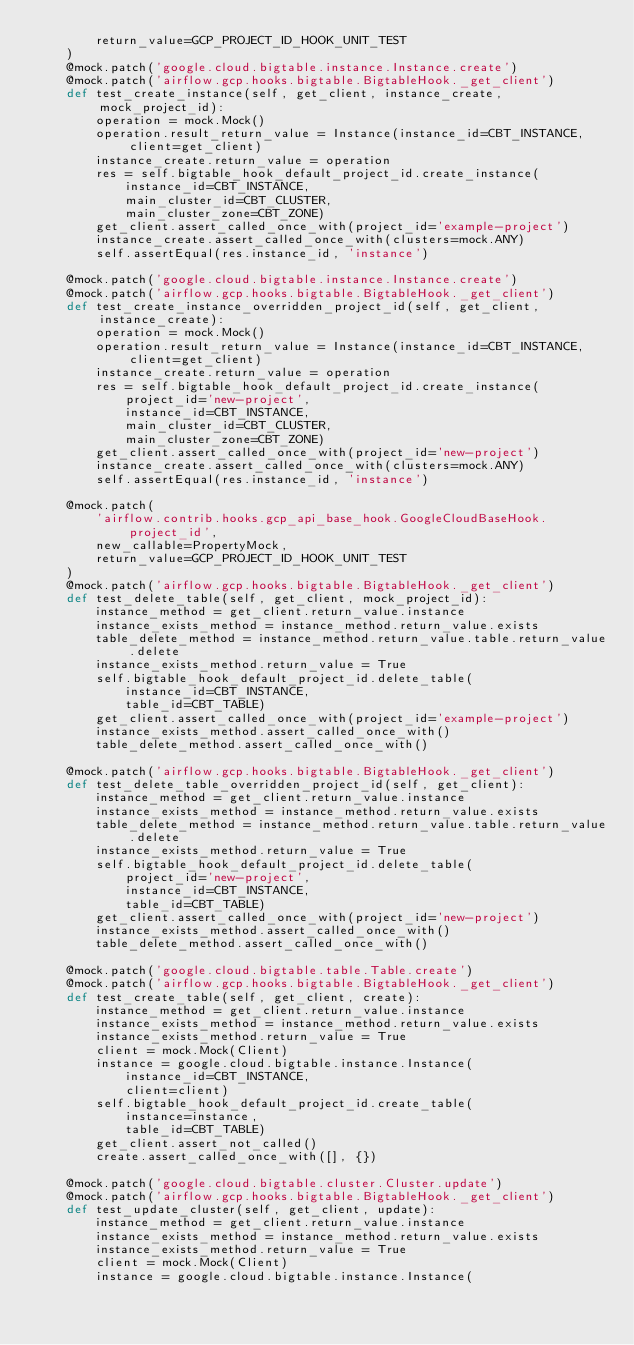<code> <loc_0><loc_0><loc_500><loc_500><_Python_>        return_value=GCP_PROJECT_ID_HOOK_UNIT_TEST
    )
    @mock.patch('google.cloud.bigtable.instance.Instance.create')
    @mock.patch('airflow.gcp.hooks.bigtable.BigtableHook._get_client')
    def test_create_instance(self, get_client, instance_create, mock_project_id):
        operation = mock.Mock()
        operation.result_return_value = Instance(instance_id=CBT_INSTANCE, client=get_client)
        instance_create.return_value = operation
        res = self.bigtable_hook_default_project_id.create_instance(
            instance_id=CBT_INSTANCE,
            main_cluster_id=CBT_CLUSTER,
            main_cluster_zone=CBT_ZONE)
        get_client.assert_called_once_with(project_id='example-project')
        instance_create.assert_called_once_with(clusters=mock.ANY)
        self.assertEqual(res.instance_id, 'instance')

    @mock.patch('google.cloud.bigtable.instance.Instance.create')
    @mock.patch('airflow.gcp.hooks.bigtable.BigtableHook._get_client')
    def test_create_instance_overridden_project_id(self, get_client, instance_create):
        operation = mock.Mock()
        operation.result_return_value = Instance(instance_id=CBT_INSTANCE, client=get_client)
        instance_create.return_value = operation
        res = self.bigtable_hook_default_project_id.create_instance(
            project_id='new-project',
            instance_id=CBT_INSTANCE,
            main_cluster_id=CBT_CLUSTER,
            main_cluster_zone=CBT_ZONE)
        get_client.assert_called_once_with(project_id='new-project')
        instance_create.assert_called_once_with(clusters=mock.ANY)
        self.assertEqual(res.instance_id, 'instance')

    @mock.patch(
        'airflow.contrib.hooks.gcp_api_base_hook.GoogleCloudBaseHook.project_id',
        new_callable=PropertyMock,
        return_value=GCP_PROJECT_ID_HOOK_UNIT_TEST
    )
    @mock.patch('airflow.gcp.hooks.bigtable.BigtableHook._get_client')
    def test_delete_table(self, get_client, mock_project_id):
        instance_method = get_client.return_value.instance
        instance_exists_method = instance_method.return_value.exists
        table_delete_method = instance_method.return_value.table.return_value.delete
        instance_exists_method.return_value = True
        self.bigtable_hook_default_project_id.delete_table(
            instance_id=CBT_INSTANCE,
            table_id=CBT_TABLE)
        get_client.assert_called_once_with(project_id='example-project')
        instance_exists_method.assert_called_once_with()
        table_delete_method.assert_called_once_with()

    @mock.patch('airflow.gcp.hooks.bigtable.BigtableHook._get_client')
    def test_delete_table_overridden_project_id(self, get_client):
        instance_method = get_client.return_value.instance
        instance_exists_method = instance_method.return_value.exists
        table_delete_method = instance_method.return_value.table.return_value.delete
        instance_exists_method.return_value = True
        self.bigtable_hook_default_project_id.delete_table(
            project_id='new-project',
            instance_id=CBT_INSTANCE,
            table_id=CBT_TABLE)
        get_client.assert_called_once_with(project_id='new-project')
        instance_exists_method.assert_called_once_with()
        table_delete_method.assert_called_once_with()

    @mock.patch('google.cloud.bigtable.table.Table.create')
    @mock.patch('airflow.gcp.hooks.bigtable.BigtableHook._get_client')
    def test_create_table(self, get_client, create):
        instance_method = get_client.return_value.instance
        instance_exists_method = instance_method.return_value.exists
        instance_exists_method.return_value = True
        client = mock.Mock(Client)
        instance = google.cloud.bigtable.instance.Instance(
            instance_id=CBT_INSTANCE,
            client=client)
        self.bigtable_hook_default_project_id.create_table(
            instance=instance,
            table_id=CBT_TABLE)
        get_client.assert_not_called()
        create.assert_called_once_with([], {})

    @mock.patch('google.cloud.bigtable.cluster.Cluster.update')
    @mock.patch('airflow.gcp.hooks.bigtable.BigtableHook._get_client')
    def test_update_cluster(self, get_client, update):
        instance_method = get_client.return_value.instance
        instance_exists_method = instance_method.return_value.exists
        instance_exists_method.return_value = True
        client = mock.Mock(Client)
        instance = google.cloud.bigtable.instance.Instance(</code> 